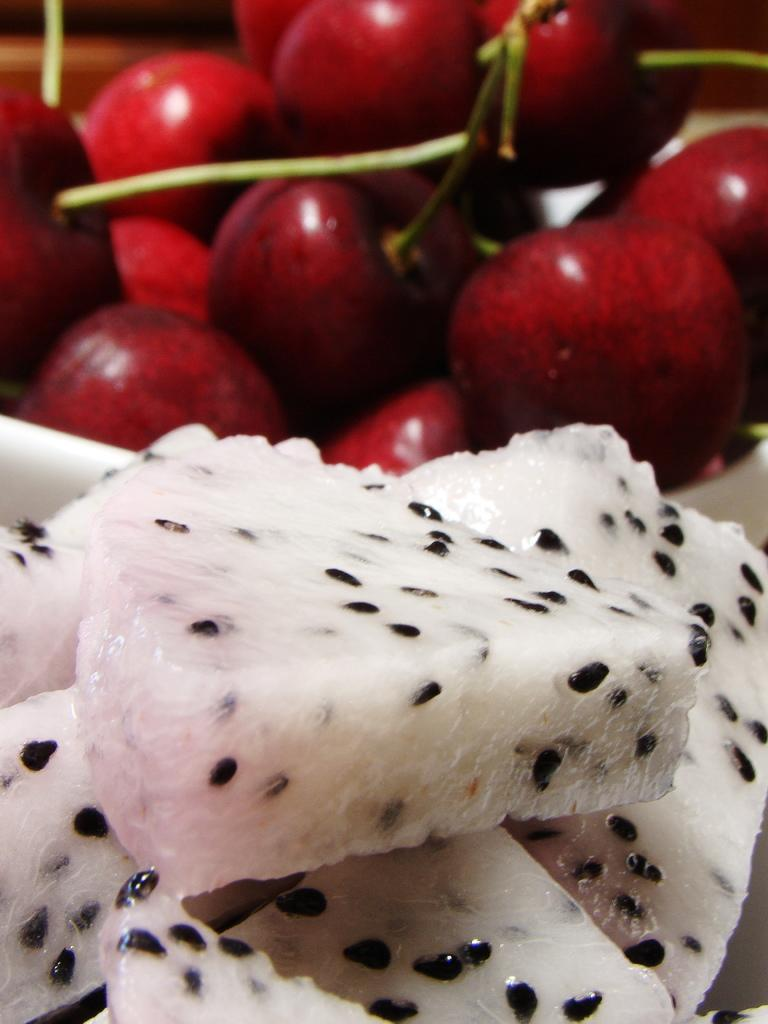What can be seen in the image related to food? There is food in the image. Can you describe the type of fruits present in the image? There are red color fruits in the image. How does the coil affect the movement of the food in the image? There is no coil present in the image, so it cannot affect the movement of the food. 